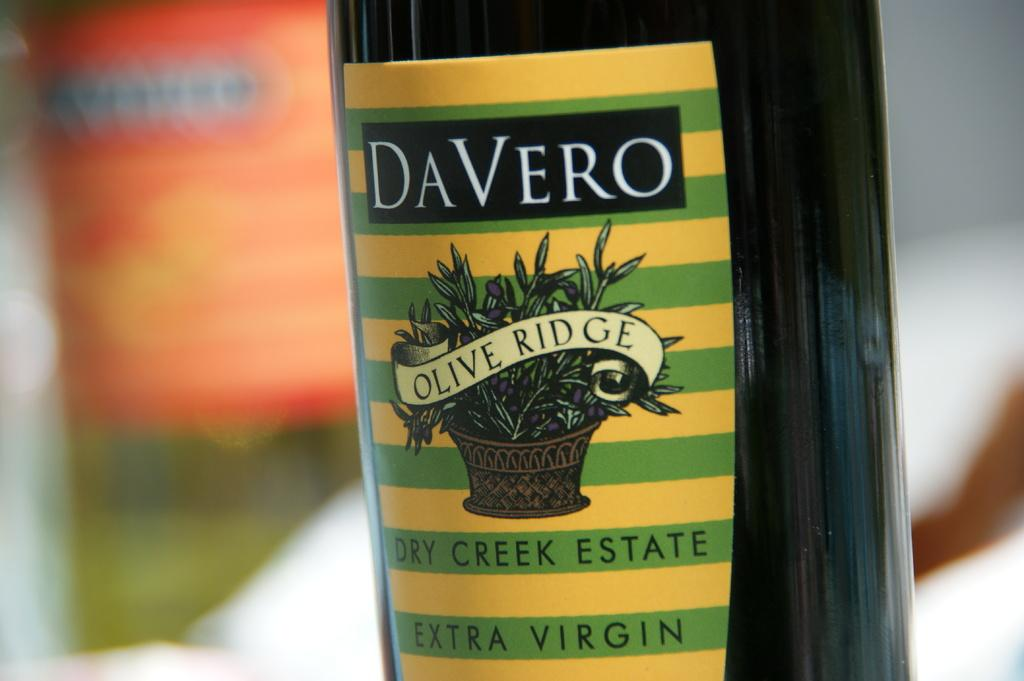What is the color of the olive oil bottle in the image? The olive oil bottle in the image is yellow and black. Can you describe the background of the image? The background of the image is blurred. What type of credit card is the queen holding in the picture? There is no queen or credit card present in the image; it only features a yellow and black olive oil bottle with a blurred background. 